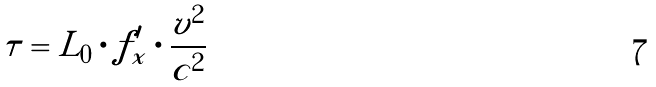Convert formula to latex. <formula><loc_0><loc_0><loc_500><loc_500>\tau = L _ { 0 } \cdot f _ { x } ^ { \prime } \cdot \frac { v ^ { 2 } } { c ^ { 2 } }</formula> 